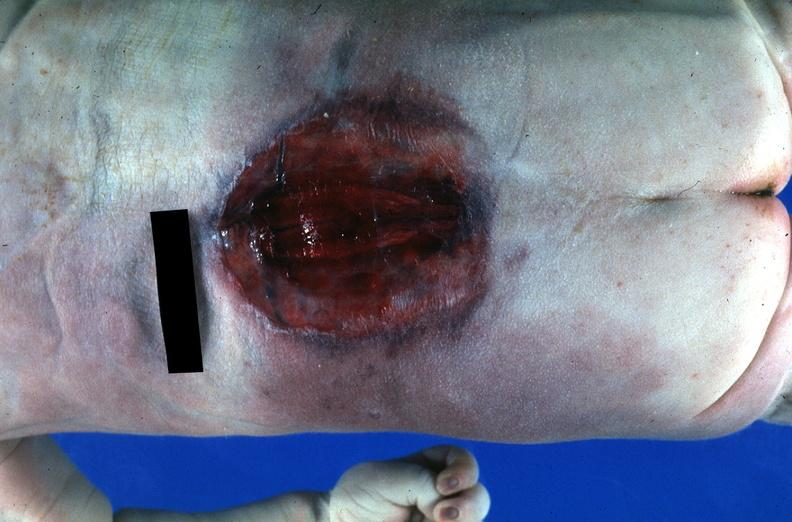does this image show neural tube defect?
Answer the question using a single word or phrase. Yes 